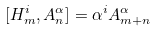Convert formula to latex. <formula><loc_0><loc_0><loc_500><loc_500>[ H ^ { i } _ { m } , A ^ { \alpha } _ { n } ] = \alpha ^ { i } A ^ { \alpha } _ { m + n }</formula> 